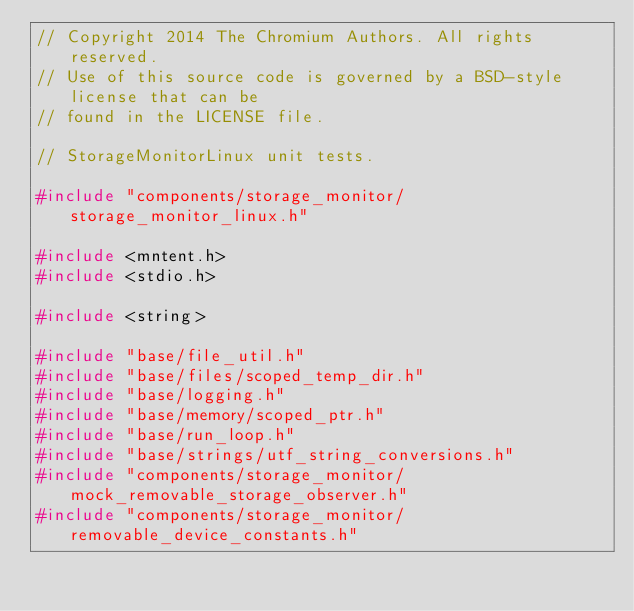<code> <loc_0><loc_0><loc_500><loc_500><_C++_>// Copyright 2014 The Chromium Authors. All rights reserved.
// Use of this source code is governed by a BSD-style license that can be
// found in the LICENSE file.

// StorageMonitorLinux unit tests.

#include "components/storage_monitor/storage_monitor_linux.h"

#include <mntent.h>
#include <stdio.h>

#include <string>

#include "base/file_util.h"
#include "base/files/scoped_temp_dir.h"
#include "base/logging.h"
#include "base/memory/scoped_ptr.h"
#include "base/run_loop.h"
#include "base/strings/utf_string_conversions.h"
#include "components/storage_monitor/mock_removable_storage_observer.h"
#include "components/storage_monitor/removable_device_constants.h"</code> 